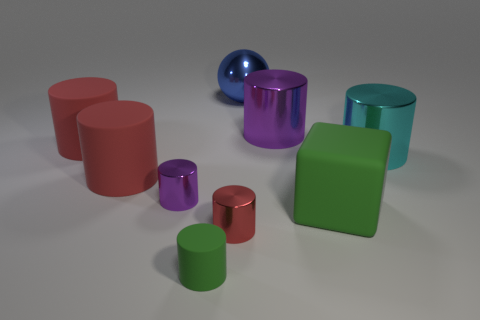Subtract all tiny purple cylinders. How many cylinders are left? 6 Subtract all green cubes. How many red cylinders are left? 3 Add 1 big balls. How many objects exist? 10 Subtract all green cylinders. How many cylinders are left? 6 Subtract 3 cylinders. How many cylinders are left? 4 Subtract all cubes. How many objects are left? 8 Subtract all blue cylinders. Subtract all gray balls. How many cylinders are left? 7 Subtract 0 purple spheres. How many objects are left? 9 Subtract all small red things. Subtract all big blue shiny things. How many objects are left? 7 Add 8 cyan shiny things. How many cyan shiny things are left? 9 